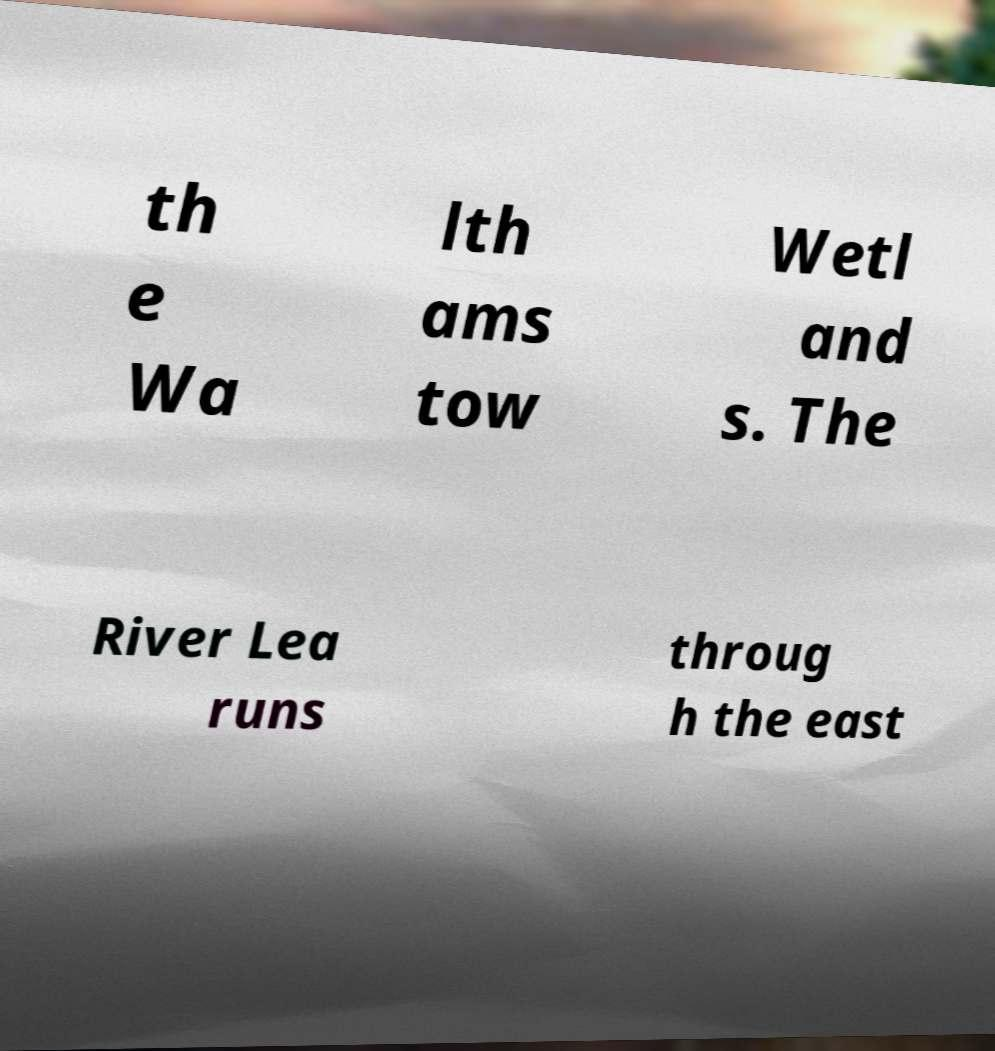Can you accurately transcribe the text from the provided image for me? th e Wa lth ams tow Wetl and s. The River Lea runs throug h the east 